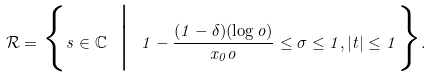Convert formula to latex. <formula><loc_0><loc_0><loc_500><loc_500>\mathcal { R } = \Big \{ s \in \mathbb { C } \ \Big | \ 1 - \frac { ( 1 - \delta ) ( \log \L o ) } { x _ { 0 } \L o } \leq \sigma \leq 1 , | t | \leq 1 \Big \} .</formula> 